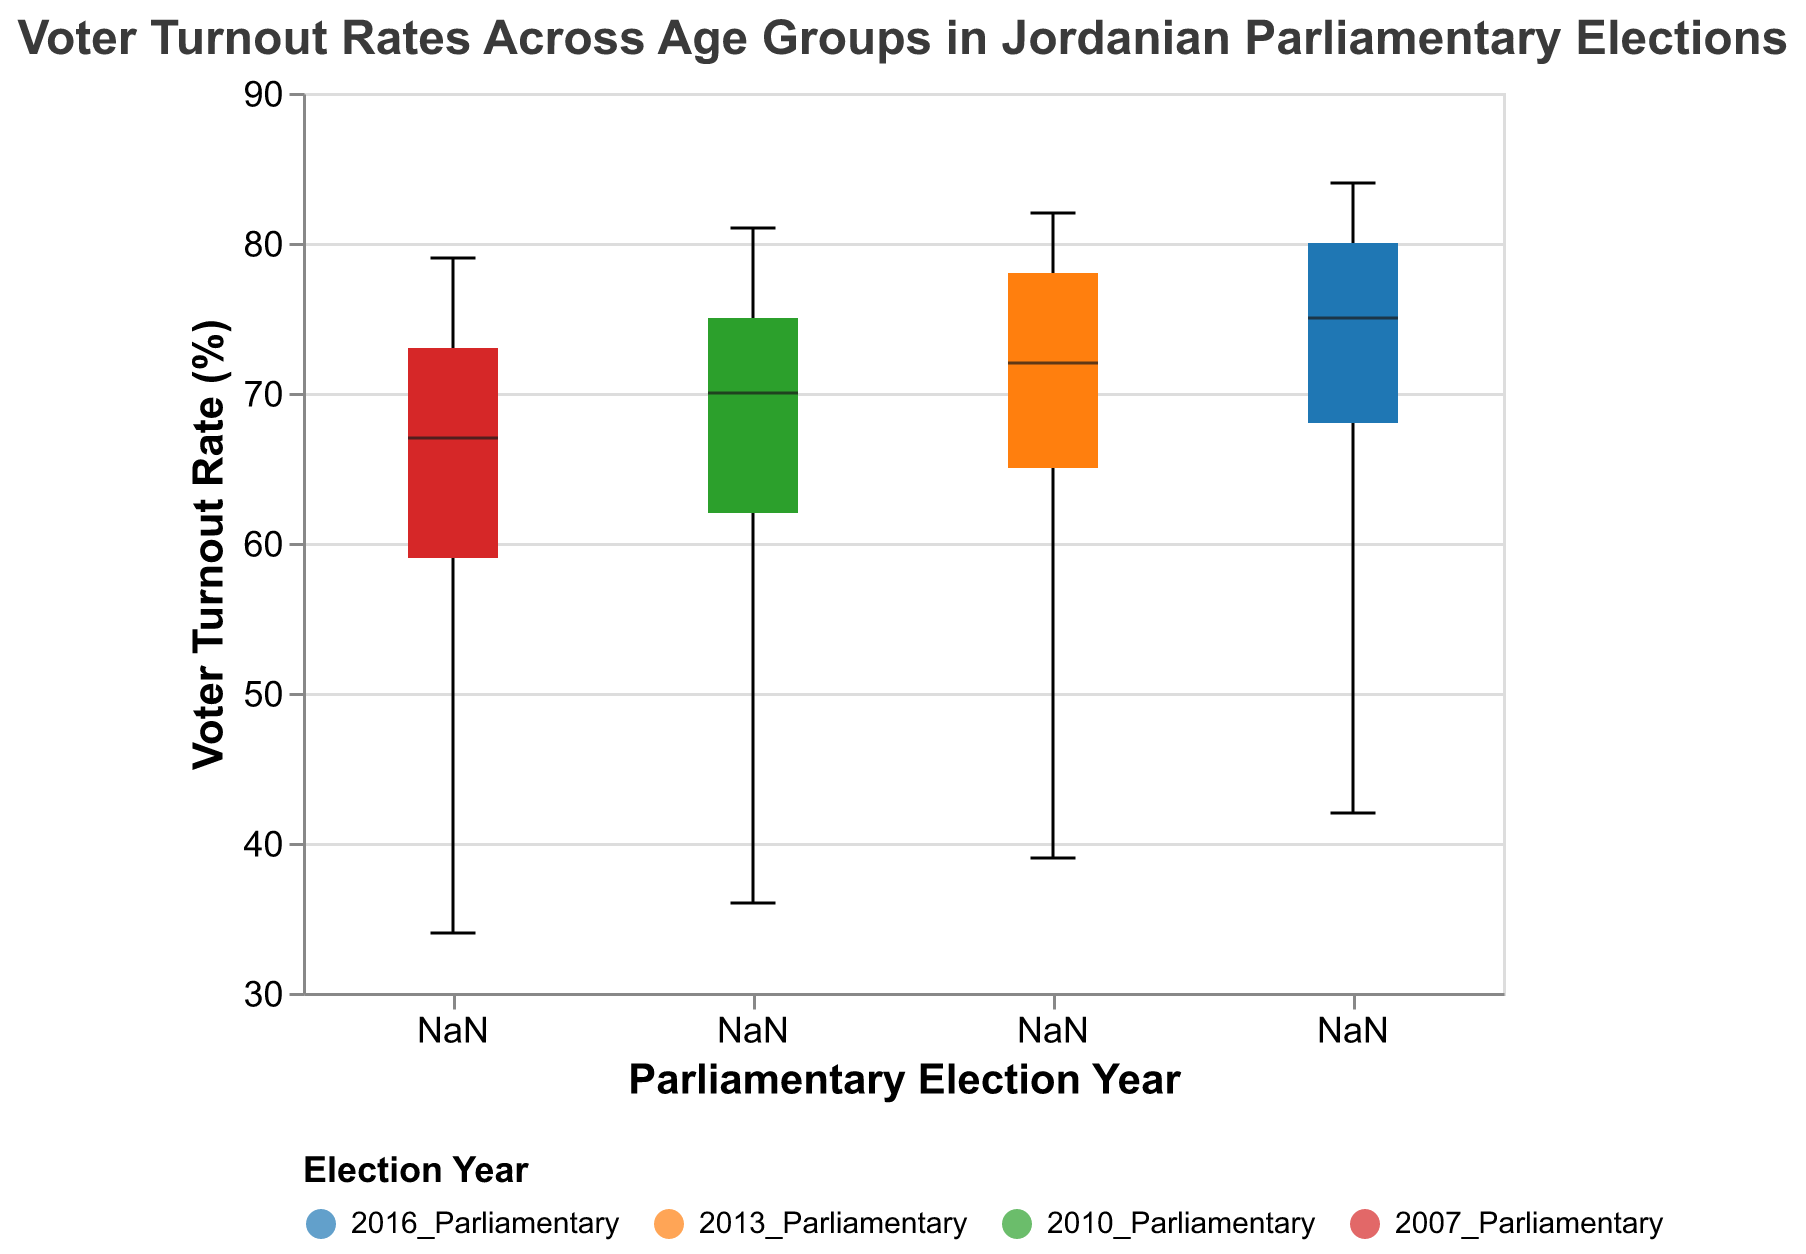Which age group had the highest voter turnout in the 2016 Parliamentary election? Look for the height of the box representing the 2016 Parliamentary election and identify which box reaches the highest point. The upper point of the box for the 60+ age group indicates the highest turnout.
Answer: 60+ What is the median voter turnout rate for the 46-60 age group across all elections? Identify the median line in the boxes corresponding to the 46-60 age group in each election year: 2016, 2013, 2010, 2007. Note that the median values are 80%, 78%, 75%, and 73% respectively. The median of these values is calculated by taking the average of the two middle values (75 and 78), which equals 76.5%.
Answer: 76.5% How does the 2010 Parliamentary election compare to the 2013 Parliamentary election in terms of median voter turnout for age group 25-35? Compare the median lines in the boxes for the 2010 and 2013 elections for the age group 25-35. For 2010, the median turnout is 62%; for 2013, it is 65%. The 2013 election has a higher median turnout by 3%.
Answer: 2013 is higher by 3% Which Parliamentary election year had the lowest voter turnout rate for the youngest age group? Examine the boxes representing the 18-24 age group and find the lowest point across all election years. The 2007 Parliamentary election has the lowest point at 34%.
Answer: 2007 What is the trend in median voter turnout rate for the 60+ age group over the elections from 2007 to 2016? Look at the median lines of the boxes representing the 60+ age group for years 2007, 2010, 2013, and 2016. The medians are 79%, 81%, 82%, and 84% respectively. The trend shows a gradual increase in median voter turnout over time.
Answer: Increasing Which age group had the most stable voter turnout rate across all elections? Look at the notched areas of the boxes for each age group across all elections. The 60+ age group shows the smallest spread in notched areas, indicating the most stable turnout.
Answer: 60+ Does the notched box plot show any statistically significant differences in voter turnout between the 2010 and 2016 elections for the age group 36-45? Compare the notches (narrowest part of the boxes) for the 36-45 age group in the 2010 and 2016 elections. Since the notches overlap, there are no statistically significant differences between these two elections in this age group.
Answer: No What is the range of voter turnout rates for the 25-35 age group in the 2007 Parliamentary election? Identify the box representing the 2007 Parliamentary election for the age group 25-35. The lower point is 59%, and the upper point is 59%. So, the range is from 59% to 59%.
Answer: 59% How do the voter turnout rates for the 46-60 age group change between each successive election? Examine the median of the 46-60 age group boxes for each election: 2007 (73%), 2010 (75%), 2013 (78%), and 2016 (80%). Calculate the differences: from 2007 to 2010 is 2%, from 2010 to 2013 is 3%, and from 2013 to 2016 is 2%.
Answer: 2%, 3%, 2% 